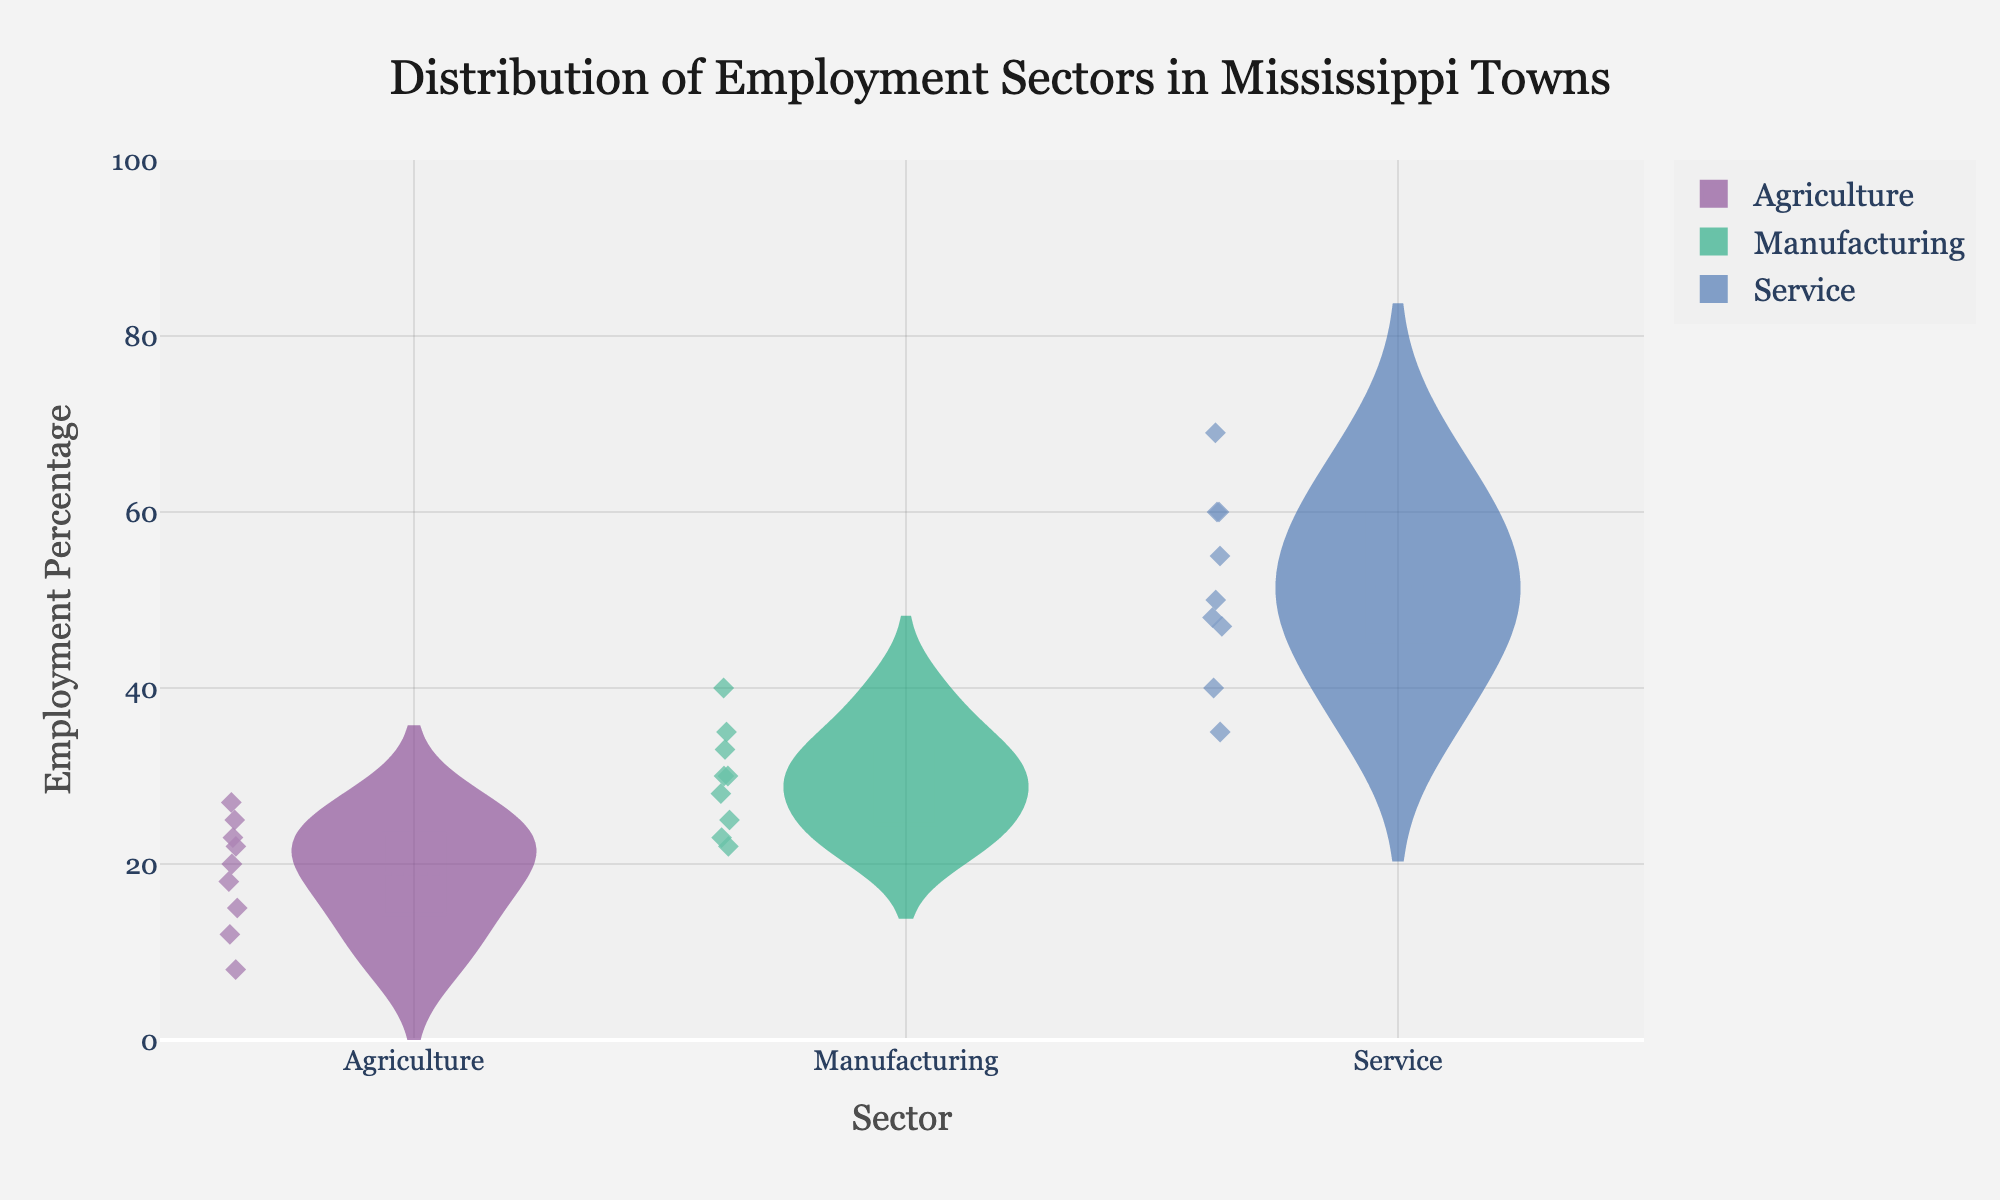What is the title of the figure? The figure's title is displayed at the top, summarizing what the chart represents. In this case, it notes the employment sectors in Mississippi towns.
Answer: Distribution of Employment Sectors in Mississippi Towns Which sector shows the highest employment percentage in Jackson? Look at the points in the violin plot for Jackson across all sectors and identify which has the highest value. Service is the sector with the highest employment percentage at 69%.
Answer: Service How many employment sectors are depicted in the violin plot? Each sector is represented as a distinct plot on the x-axis. Count these distinct categories.
Answer: 3 Which town has the lowest percentage in the Agriculture sector? Find the points for all towns in the Agriculture sector and identify the lowest one. Jackson has the lowest with 8%.
Answer: Jackson What is the average employment percentage for the Manufacturing sector? Add up the employment percentages for Manufacturing across all towns and divide by the number of towns. (25+30+28+35+30+33+23+40+22)/9 = 29.6.
Answer: 29.6 Are there outliers in the Service sector, and if so, which towns are they? Identify if any points in the Service sector are significantly higher or lower than others. Jackson (69%) stands out as an outlier compared to other towns.
Answer: Jackson What is the median employment percentage for the Agriculture sector? Arrange the employment percentages in ascending order and find the middle value. The rates are 8, 12, 15, 18, 20, 22, 23, 25, 27. The median is (20+22)/2 = 21.
Answer: 21 Which sector has the lowest variability in employment percentages? Examine the spread and interquartile range (IQR) for each sector. Agriculture has the smallest spread, indicating the least variability compared to Service and Manufacturing.
Answer: Agriculture Which towns have an employment percentage in the Service sector of exactly 60%? Look at the points in the Service sector and note the towns with the exact value of 60%. Greenville and Clarksdale both show 60%.
Answer: Greenville, Clarksdale 